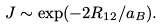Convert formula to latex. <formula><loc_0><loc_0><loc_500><loc_500>J \sim \exp ( - 2 R _ { 1 2 } / a _ { B } ) .</formula> 